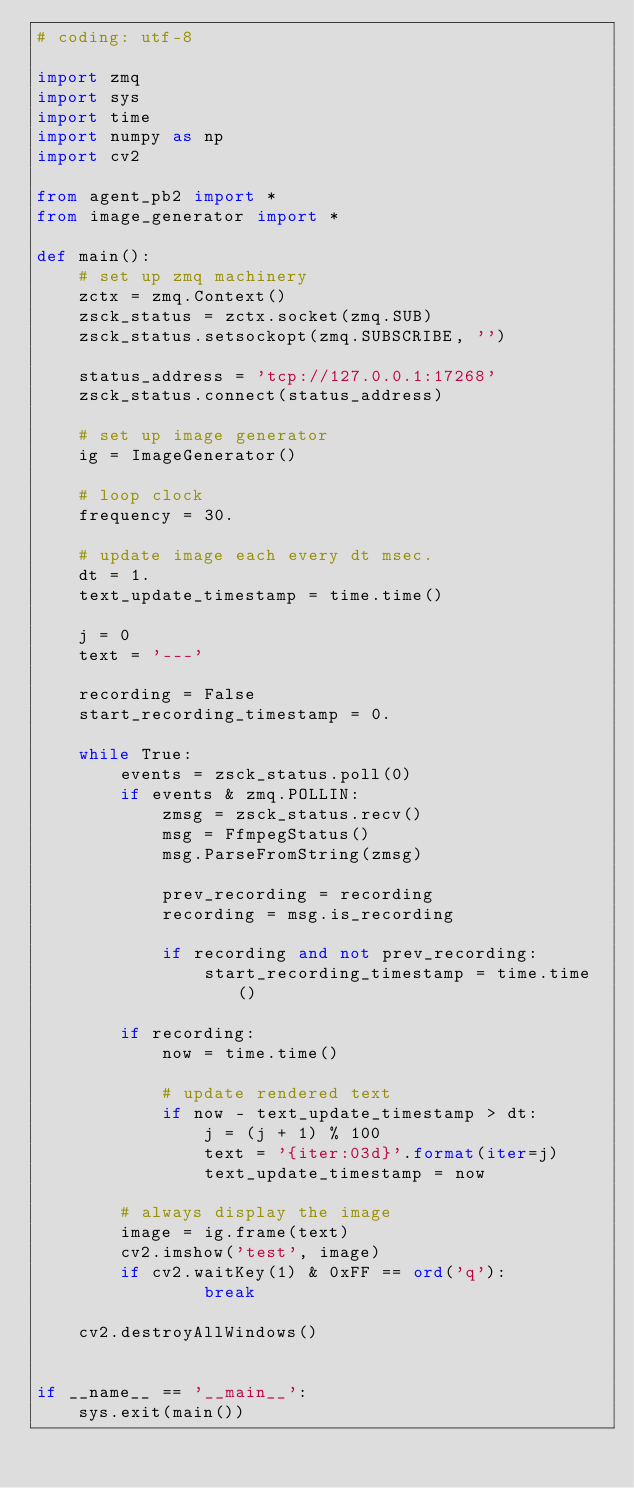Convert code to text. <code><loc_0><loc_0><loc_500><loc_500><_Python_># coding: utf-8

import zmq
import sys
import time
import numpy as np
import cv2

from agent_pb2 import *
from image_generator import *

def main():
    # set up zmq machinery
    zctx = zmq.Context()
    zsck_status = zctx.socket(zmq.SUB)
    zsck_status.setsockopt(zmq.SUBSCRIBE, '')

    status_address = 'tcp://127.0.0.1:17268'
    zsck_status.connect(status_address)

    # set up image generator
    ig = ImageGenerator()

    # loop clock
    frequency = 30.

    # update image each every dt msec.
    dt = 1.
    text_update_timestamp = time.time()

    j = 0
    text = '---'

    recording = False
    start_recording_timestamp = 0.

    while True:
        events = zsck_status.poll(0)
        if events & zmq.POLLIN:
            zmsg = zsck_status.recv()
            msg = FfmpegStatus()
            msg.ParseFromString(zmsg)

            prev_recording = recording
            recording = msg.is_recording

            if recording and not prev_recording:
                start_recording_timestamp = time.time()

        if recording:
            now = time.time()

            # update rendered text
            if now - text_update_timestamp > dt:
                j = (j + 1) % 100
                text = '{iter:03d}'.format(iter=j)
                text_update_timestamp = now

        # always display the image
        image = ig.frame(text)
        cv2.imshow('test', image)
        if cv2.waitKey(1) & 0xFF == ord('q'):
                break

    cv2.destroyAllWindows()


if __name__ == '__main__':
    sys.exit(main())


</code> 